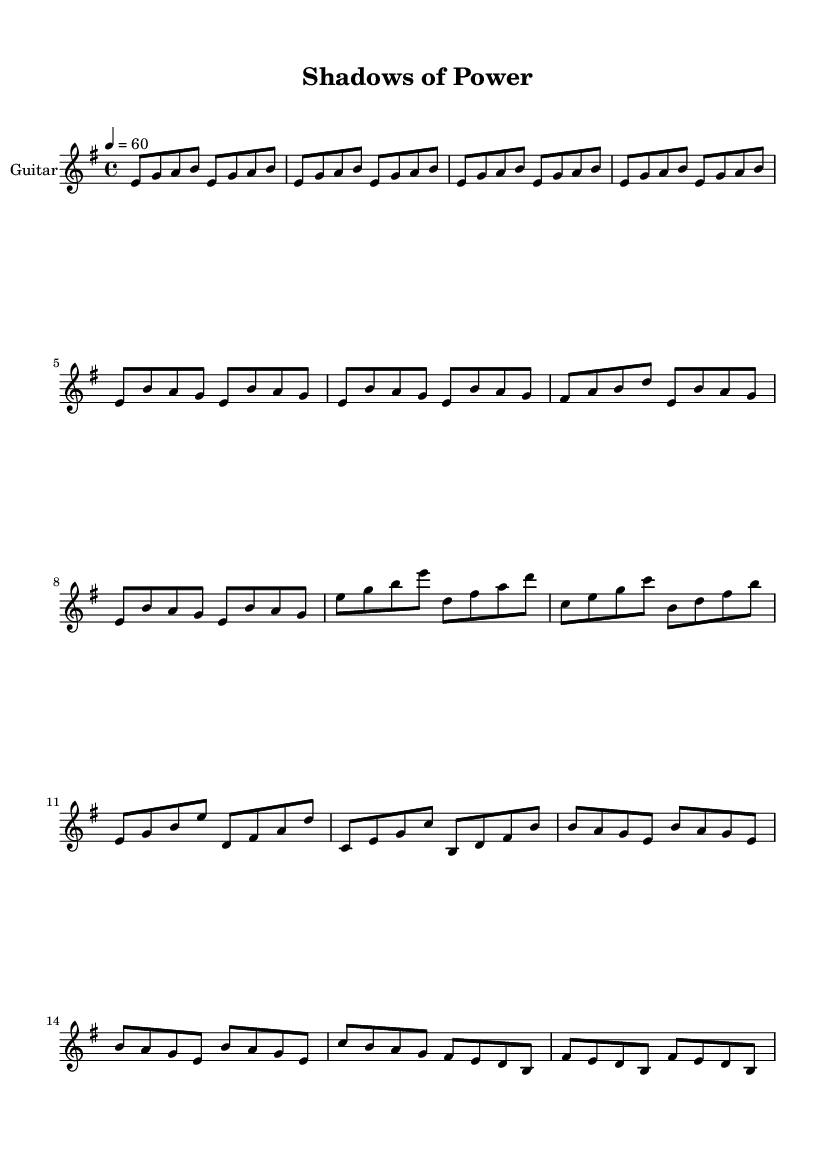What is the key signature of this music? The key signature is E minor, which has one sharp (F#) indicating the scale.
Answer: E minor What is the time signature of this piece? The time signature is 4/4, which means there are four beats per measure and the quarter note gets one beat.
Answer: 4/4 What is the tempo marking of the music? The tempo marking is 60 beats per minute, which indicates a slow pace, typical for a ballad.
Answer: 60 How many measures are in the introductory section? The introductory section consists of four measures, each containing the same rhythmic pattern repeated.
Answer: 4 What is the highest note in the chorus? The highest note in the chorus is B, which appears prominently as part of the melodic line.
Answer: B What structural element follows the chorus in the composition? The structural element that follows the chorus is the bridge, which provides contrast in melody and harmony.
Answer: Bridge Identify the primary instrument indicated in the score. The primary instrument indicated in the score is the guitar, as specified at the beginning of the staff.
Answer: Guitar 